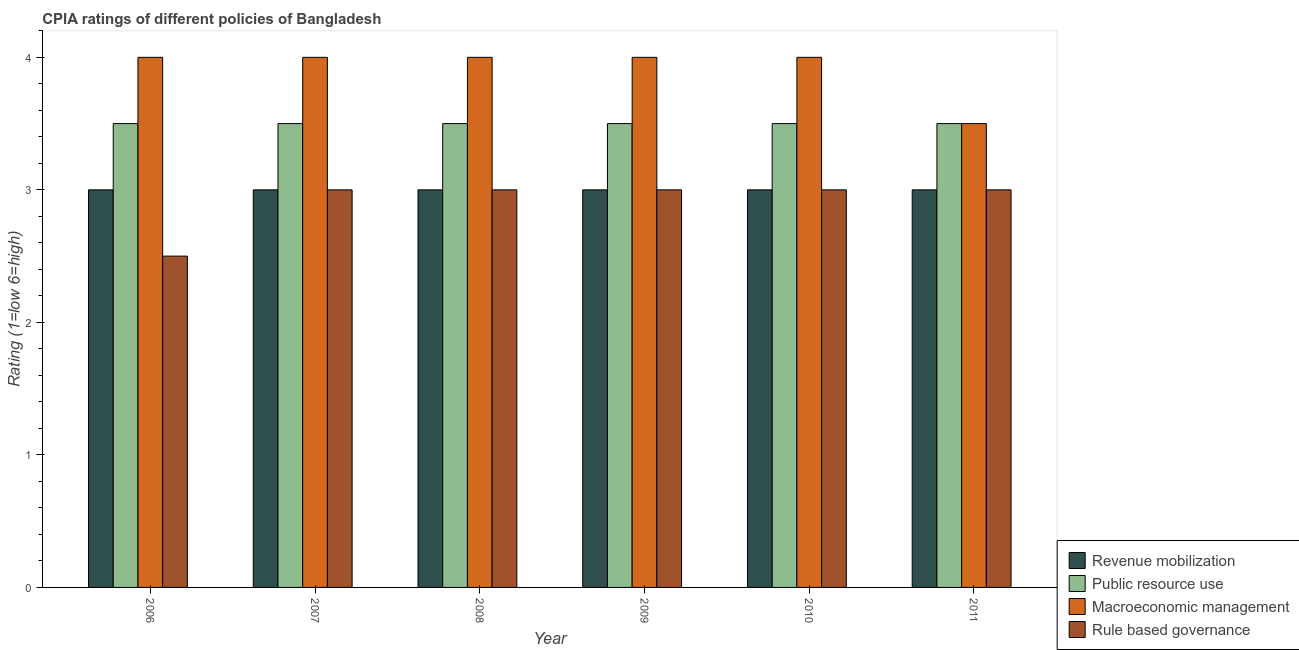How many different coloured bars are there?
Provide a succinct answer. 4. How many groups of bars are there?
Make the answer very short. 6. Are the number of bars per tick equal to the number of legend labels?
Provide a short and direct response. Yes. How many bars are there on the 2nd tick from the left?
Your answer should be very brief. 4. How many bars are there on the 6th tick from the right?
Your response must be concise. 4. What is the label of the 5th group of bars from the left?
Your response must be concise. 2010. Across all years, what is the minimum cpia rating of macroeconomic management?
Offer a terse response. 3.5. In which year was the cpia rating of macroeconomic management maximum?
Ensure brevity in your answer.  2006. What is the total cpia rating of revenue mobilization in the graph?
Your answer should be compact. 18. What is the difference between the cpia rating of rule based governance in 2010 and that in 2011?
Provide a short and direct response. 0. What is the average cpia rating of macroeconomic management per year?
Keep it short and to the point. 3.92. In the year 2011, what is the difference between the cpia rating of public resource use and cpia rating of rule based governance?
Make the answer very short. 0. In how many years, is the cpia rating of public resource use greater than 0.2?
Your answer should be very brief. 6. Is the difference between the cpia rating of rule based governance in 2010 and 2011 greater than the difference between the cpia rating of public resource use in 2010 and 2011?
Give a very brief answer. No. What is the difference between the highest and the lowest cpia rating of revenue mobilization?
Provide a succinct answer. 0. Is it the case that in every year, the sum of the cpia rating of rule based governance and cpia rating of revenue mobilization is greater than the sum of cpia rating of macroeconomic management and cpia rating of public resource use?
Give a very brief answer. No. What does the 1st bar from the left in 2007 represents?
Offer a very short reply. Revenue mobilization. What does the 3rd bar from the right in 2008 represents?
Ensure brevity in your answer.  Public resource use. Is it the case that in every year, the sum of the cpia rating of revenue mobilization and cpia rating of public resource use is greater than the cpia rating of macroeconomic management?
Offer a terse response. Yes. How many bars are there?
Give a very brief answer. 24. Are all the bars in the graph horizontal?
Ensure brevity in your answer.  No. Does the graph contain any zero values?
Your answer should be compact. No. Does the graph contain grids?
Give a very brief answer. No. What is the title of the graph?
Keep it short and to the point. CPIA ratings of different policies of Bangladesh. Does "Other expenses" appear as one of the legend labels in the graph?
Your answer should be compact. No. What is the label or title of the X-axis?
Provide a short and direct response. Year. What is the Rating (1=low 6=high) of Public resource use in 2006?
Make the answer very short. 3.5. What is the Rating (1=low 6=high) in Macroeconomic management in 2006?
Offer a terse response. 4. What is the Rating (1=low 6=high) in Revenue mobilization in 2007?
Keep it short and to the point. 3. What is the Rating (1=low 6=high) in Public resource use in 2007?
Provide a succinct answer. 3.5. What is the Rating (1=low 6=high) of Macroeconomic management in 2007?
Offer a very short reply. 4. What is the Rating (1=low 6=high) in Rule based governance in 2007?
Provide a succinct answer. 3. What is the Rating (1=low 6=high) in Macroeconomic management in 2008?
Give a very brief answer. 4. What is the Rating (1=low 6=high) of Macroeconomic management in 2009?
Make the answer very short. 4. What is the Rating (1=low 6=high) of Macroeconomic management in 2010?
Your answer should be compact. 4. What is the Rating (1=low 6=high) in Rule based governance in 2010?
Provide a short and direct response. 3. What is the Rating (1=low 6=high) of Macroeconomic management in 2011?
Give a very brief answer. 3.5. Across all years, what is the maximum Rating (1=low 6=high) of Public resource use?
Provide a succinct answer. 3.5. Across all years, what is the minimum Rating (1=low 6=high) in Public resource use?
Offer a terse response. 3.5. Across all years, what is the minimum Rating (1=low 6=high) of Rule based governance?
Provide a short and direct response. 2.5. What is the total Rating (1=low 6=high) of Revenue mobilization in the graph?
Keep it short and to the point. 18. What is the total Rating (1=low 6=high) in Rule based governance in the graph?
Offer a very short reply. 17.5. What is the difference between the Rating (1=low 6=high) of Macroeconomic management in 2006 and that in 2007?
Ensure brevity in your answer.  0. What is the difference between the Rating (1=low 6=high) of Revenue mobilization in 2006 and that in 2008?
Keep it short and to the point. 0. What is the difference between the Rating (1=low 6=high) of Macroeconomic management in 2006 and that in 2008?
Give a very brief answer. 0. What is the difference between the Rating (1=low 6=high) of Revenue mobilization in 2006 and that in 2009?
Ensure brevity in your answer.  0. What is the difference between the Rating (1=low 6=high) in Rule based governance in 2006 and that in 2009?
Ensure brevity in your answer.  -0.5. What is the difference between the Rating (1=low 6=high) of Public resource use in 2006 and that in 2010?
Your answer should be very brief. 0. What is the difference between the Rating (1=low 6=high) of Revenue mobilization in 2006 and that in 2011?
Offer a very short reply. 0. What is the difference between the Rating (1=low 6=high) in Public resource use in 2006 and that in 2011?
Offer a terse response. 0. What is the difference between the Rating (1=low 6=high) of Macroeconomic management in 2006 and that in 2011?
Make the answer very short. 0.5. What is the difference between the Rating (1=low 6=high) in Revenue mobilization in 2007 and that in 2008?
Provide a short and direct response. 0. What is the difference between the Rating (1=low 6=high) of Public resource use in 2007 and that in 2008?
Give a very brief answer. 0. What is the difference between the Rating (1=low 6=high) in Rule based governance in 2007 and that in 2008?
Provide a short and direct response. 0. What is the difference between the Rating (1=low 6=high) in Public resource use in 2007 and that in 2009?
Your response must be concise. 0. What is the difference between the Rating (1=low 6=high) in Rule based governance in 2007 and that in 2009?
Make the answer very short. 0. What is the difference between the Rating (1=low 6=high) in Revenue mobilization in 2007 and that in 2010?
Ensure brevity in your answer.  0. What is the difference between the Rating (1=low 6=high) in Revenue mobilization in 2007 and that in 2011?
Your answer should be very brief. 0. What is the difference between the Rating (1=low 6=high) in Macroeconomic management in 2007 and that in 2011?
Offer a terse response. 0.5. What is the difference between the Rating (1=low 6=high) in Rule based governance in 2007 and that in 2011?
Make the answer very short. 0. What is the difference between the Rating (1=low 6=high) in Revenue mobilization in 2008 and that in 2009?
Provide a short and direct response. 0. What is the difference between the Rating (1=low 6=high) of Macroeconomic management in 2008 and that in 2009?
Your response must be concise. 0. What is the difference between the Rating (1=low 6=high) in Revenue mobilization in 2008 and that in 2010?
Give a very brief answer. 0. What is the difference between the Rating (1=low 6=high) of Rule based governance in 2008 and that in 2010?
Provide a short and direct response. 0. What is the difference between the Rating (1=low 6=high) of Rule based governance in 2008 and that in 2011?
Your answer should be very brief. 0. What is the difference between the Rating (1=low 6=high) of Revenue mobilization in 2009 and that in 2010?
Give a very brief answer. 0. What is the difference between the Rating (1=low 6=high) of Macroeconomic management in 2009 and that in 2010?
Your answer should be very brief. 0. What is the difference between the Rating (1=low 6=high) in Revenue mobilization in 2009 and that in 2011?
Offer a very short reply. 0. What is the difference between the Rating (1=low 6=high) in Macroeconomic management in 2009 and that in 2011?
Keep it short and to the point. 0.5. What is the difference between the Rating (1=low 6=high) of Rule based governance in 2010 and that in 2011?
Your response must be concise. 0. What is the difference between the Rating (1=low 6=high) of Revenue mobilization in 2006 and the Rating (1=low 6=high) of Public resource use in 2007?
Provide a succinct answer. -0.5. What is the difference between the Rating (1=low 6=high) of Revenue mobilization in 2006 and the Rating (1=low 6=high) of Macroeconomic management in 2007?
Provide a short and direct response. -1. What is the difference between the Rating (1=low 6=high) of Revenue mobilization in 2006 and the Rating (1=low 6=high) of Public resource use in 2008?
Make the answer very short. -0.5. What is the difference between the Rating (1=low 6=high) of Public resource use in 2006 and the Rating (1=low 6=high) of Macroeconomic management in 2008?
Your answer should be compact. -0.5. What is the difference between the Rating (1=low 6=high) in Revenue mobilization in 2006 and the Rating (1=low 6=high) in Macroeconomic management in 2009?
Give a very brief answer. -1. What is the difference between the Rating (1=low 6=high) of Revenue mobilization in 2006 and the Rating (1=low 6=high) of Rule based governance in 2009?
Keep it short and to the point. 0. What is the difference between the Rating (1=low 6=high) in Public resource use in 2006 and the Rating (1=low 6=high) in Rule based governance in 2009?
Keep it short and to the point. 0.5. What is the difference between the Rating (1=low 6=high) of Macroeconomic management in 2006 and the Rating (1=low 6=high) of Rule based governance in 2009?
Your answer should be very brief. 1. What is the difference between the Rating (1=low 6=high) in Revenue mobilization in 2006 and the Rating (1=low 6=high) in Public resource use in 2010?
Offer a very short reply. -0.5. What is the difference between the Rating (1=low 6=high) in Public resource use in 2006 and the Rating (1=low 6=high) in Macroeconomic management in 2010?
Make the answer very short. -0.5. What is the difference between the Rating (1=low 6=high) in Public resource use in 2006 and the Rating (1=low 6=high) in Rule based governance in 2010?
Make the answer very short. 0.5. What is the difference between the Rating (1=low 6=high) in Macroeconomic management in 2006 and the Rating (1=low 6=high) in Rule based governance in 2010?
Ensure brevity in your answer.  1. What is the difference between the Rating (1=low 6=high) in Revenue mobilization in 2006 and the Rating (1=low 6=high) in Rule based governance in 2011?
Offer a very short reply. 0. What is the difference between the Rating (1=low 6=high) in Public resource use in 2006 and the Rating (1=low 6=high) in Rule based governance in 2011?
Keep it short and to the point. 0.5. What is the difference between the Rating (1=low 6=high) of Macroeconomic management in 2006 and the Rating (1=low 6=high) of Rule based governance in 2011?
Provide a succinct answer. 1. What is the difference between the Rating (1=low 6=high) of Revenue mobilization in 2007 and the Rating (1=low 6=high) of Public resource use in 2008?
Make the answer very short. -0.5. What is the difference between the Rating (1=low 6=high) in Revenue mobilization in 2007 and the Rating (1=low 6=high) in Macroeconomic management in 2008?
Keep it short and to the point. -1. What is the difference between the Rating (1=low 6=high) of Public resource use in 2007 and the Rating (1=low 6=high) of Macroeconomic management in 2008?
Provide a succinct answer. -0.5. What is the difference between the Rating (1=low 6=high) of Public resource use in 2007 and the Rating (1=low 6=high) of Rule based governance in 2008?
Give a very brief answer. 0.5. What is the difference between the Rating (1=low 6=high) in Revenue mobilization in 2007 and the Rating (1=low 6=high) in Public resource use in 2009?
Your answer should be compact. -0.5. What is the difference between the Rating (1=low 6=high) in Public resource use in 2007 and the Rating (1=low 6=high) in Rule based governance in 2009?
Your answer should be very brief. 0.5. What is the difference between the Rating (1=low 6=high) of Revenue mobilization in 2007 and the Rating (1=low 6=high) of Macroeconomic management in 2010?
Offer a terse response. -1. What is the difference between the Rating (1=low 6=high) in Public resource use in 2007 and the Rating (1=low 6=high) in Rule based governance in 2010?
Your response must be concise. 0.5. What is the difference between the Rating (1=low 6=high) in Revenue mobilization in 2007 and the Rating (1=low 6=high) in Public resource use in 2011?
Make the answer very short. -0.5. What is the difference between the Rating (1=low 6=high) in Public resource use in 2007 and the Rating (1=low 6=high) in Rule based governance in 2011?
Provide a succinct answer. 0.5. What is the difference between the Rating (1=low 6=high) in Revenue mobilization in 2008 and the Rating (1=low 6=high) in Public resource use in 2009?
Provide a short and direct response. -0.5. What is the difference between the Rating (1=low 6=high) of Revenue mobilization in 2008 and the Rating (1=low 6=high) of Macroeconomic management in 2009?
Offer a very short reply. -1. What is the difference between the Rating (1=low 6=high) of Revenue mobilization in 2008 and the Rating (1=low 6=high) of Rule based governance in 2009?
Make the answer very short. 0. What is the difference between the Rating (1=low 6=high) in Macroeconomic management in 2008 and the Rating (1=low 6=high) in Rule based governance in 2009?
Your answer should be compact. 1. What is the difference between the Rating (1=low 6=high) of Public resource use in 2008 and the Rating (1=low 6=high) of Macroeconomic management in 2010?
Your answer should be very brief. -0.5. What is the difference between the Rating (1=low 6=high) in Public resource use in 2008 and the Rating (1=low 6=high) in Rule based governance in 2010?
Ensure brevity in your answer.  0.5. What is the difference between the Rating (1=low 6=high) in Revenue mobilization in 2008 and the Rating (1=low 6=high) in Public resource use in 2011?
Offer a terse response. -0.5. What is the difference between the Rating (1=low 6=high) in Revenue mobilization in 2008 and the Rating (1=low 6=high) in Macroeconomic management in 2011?
Your answer should be very brief. -0.5. What is the difference between the Rating (1=low 6=high) in Revenue mobilization in 2008 and the Rating (1=low 6=high) in Rule based governance in 2011?
Your answer should be compact. 0. What is the difference between the Rating (1=low 6=high) of Public resource use in 2008 and the Rating (1=low 6=high) of Rule based governance in 2011?
Keep it short and to the point. 0.5. What is the difference between the Rating (1=low 6=high) of Macroeconomic management in 2008 and the Rating (1=low 6=high) of Rule based governance in 2011?
Make the answer very short. 1. What is the difference between the Rating (1=low 6=high) of Revenue mobilization in 2009 and the Rating (1=low 6=high) of Macroeconomic management in 2010?
Your response must be concise. -1. What is the difference between the Rating (1=low 6=high) of Revenue mobilization in 2009 and the Rating (1=low 6=high) of Rule based governance in 2010?
Keep it short and to the point. 0. What is the difference between the Rating (1=low 6=high) of Public resource use in 2009 and the Rating (1=low 6=high) of Macroeconomic management in 2010?
Give a very brief answer. -0.5. What is the difference between the Rating (1=low 6=high) of Public resource use in 2009 and the Rating (1=low 6=high) of Rule based governance in 2010?
Provide a succinct answer. 0.5. What is the difference between the Rating (1=low 6=high) of Macroeconomic management in 2009 and the Rating (1=low 6=high) of Rule based governance in 2010?
Keep it short and to the point. 1. What is the difference between the Rating (1=low 6=high) in Revenue mobilization in 2009 and the Rating (1=low 6=high) in Public resource use in 2011?
Keep it short and to the point. -0.5. What is the difference between the Rating (1=low 6=high) of Public resource use in 2009 and the Rating (1=low 6=high) of Rule based governance in 2011?
Make the answer very short. 0.5. What is the difference between the Rating (1=low 6=high) in Macroeconomic management in 2009 and the Rating (1=low 6=high) in Rule based governance in 2011?
Your answer should be compact. 1. What is the difference between the Rating (1=low 6=high) in Revenue mobilization in 2010 and the Rating (1=low 6=high) in Public resource use in 2011?
Your response must be concise. -0.5. What is the difference between the Rating (1=low 6=high) of Revenue mobilization in 2010 and the Rating (1=low 6=high) of Macroeconomic management in 2011?
Your answer should be compact. -0.5. What is the difference between the Rating (1=low 6=high) of Revenue mobilization in 2010 and the Rating (1=low 6=high) of Rule based governance in 2011?
Give a very brief answer. 0. What is the difference between the Rating (1=low 6=high) in Public resource use in 2010 and the Rating (1=low 6=high) in Rule based governance in 2011?
Give a very brief answer. 0.5. What is the difference between the Rating (1=low 6=high) of Macroeconomic management in 2010 and the Rating (1=low 6=high) of Rule based governance in 2011?
Keep it short and to the point. 1. What is the average Rating (1=low 6=high) in Revenue mobilization per year?
Make the answer very short. 3. What is the average Rating (1=low 6=high) in Macroeconomic management per year?
Provide a succinct answer. 3.92. What is the average Rating (1=low 6=high) in Rule based governance per year?
Ensure brevity in your answer.  2.92. In the year 2006, what is the difference between the Rating (1=low 6=high) of Revenue mobilization and Rating (1=low 6=high) of Macroeconomic management?
Your answer should be very brief. -1. In the year 2006, what is the difference between the Rating (1=low 6=high) in Public resource use and Rating (1=low 6=high) in Macroeconomic management?
Provide a short and direct response. -0.5. In the year 2006, what is the difference between the Rating (1=low 6=high) of Macroeconomic management and Rating (1=low 6=high) of Rule based governance?
Your answer should be compact. 1.5. In the year 2007, what is the difference between the Rating (1=low 6=high) of Revenue mobilization and Rating (1=low 6=high) of Macroeconomic management?
Your response must be concise. -1. In the year 2007, what is the difference between the Rating (1=low 6=high) of Public resource use and Rating (1=low 6=high) of Macroeconomic management?
Ensure brevity in your answer.  -0.5. In the year 2007, what is the difference between the Rating (1=low 6=high) in Macroeconomic management and Rating (1=low 6=high) in Rule based governance?
Your answer should be compact. 1. In the year 2008, what is the difference between the Rating (1=low 6=high) in Revenue mobilization and Rating (1=low 6=high) in Public resource use?
Offer a terse response. -0.5. In the year 2008, what is the difference between the Rating (1=low 6=high) in Public resource use and Rating (1=low 6=high) in Macroeconomic management?
Provide a short and direct response. -0.5. In the year 2009, what is the difference between the Rating (1=low 6=high) in Revenue mobilization and Rating (1=low 6=high) in Public resource use?
Ensure brevity in your answer.  -0.5. In the year 2009, what is the difference between the Rating (1=low 6=high) in Macroeconomic management and Rating (1=low 6=high) in Rule based governance?
Offer a terse response. 1. In the year 2010, what is the difference between the Rating (1=low 6=high) in Revenue mobilization and Rating (1=low 6=high) in Public resource use?
Offer a terse response. -0.5. In the year 2010, what is the difference between the Rating (1=low 6=high) in Revenue mobilization and Rating (1=low 6=high) in Rule based governance?
Keep it short and to the point. 0. In the year 2010, what is the difference between the Rating (1=low 6=high) in Public resource use and Rating (1=low 6=high) in Rule based governance?
Provide a succinct answer. 0.5. In the year 2010, what is the difference between the Rating (1=low 6=high) in Macroeconomic management and Rating (1=low 6=high) in Rule based governance?
Provide a short and direct response. 1. In the year 2011, what is the difference between the Rating (1=low 6=high) in Revenue mobilization and Rating (1=low 6=high) in Macroeconomic management?
Offer a very short reply. -0.5. In the year 2011, what is the difference between the Rating (1=low 6=high) in Public resource use and Rating (1=low 6=high) in Macroeconomic management?
Your answer should be compact. 0. In the year 2011, what is the difference between the Rating (1=low 6=high) of Public resource use and Rating (1=low 6=high) of Rule based governance?
Your answer should be compact. 0.5. What is the ratio of the Rating (1=low 6=high) of Public resource use in 2006 to that in 2007?
Your response must be concise. 1. What is the ratio of the Rating (1=low 6=high) of Rule based governance in 2006 to that in 2007?
Your answer should be compact. 0.83. What is the ratio of the Rating (1=low 6=high) in Public resource use in 2006 to that in 2008?
Keep it short and to the point. 1. What is the ratio of the Rating (1=low 6=high) in Macroeconomic management in 2006 to that in 2008?
Your answer should be compact. 1. What is the ratio of the Rating (1=low 6=high) in Revenue mobilization in 2006 to that in 2009?
Keep it short and to the point. 1. What is the ratio of the Rating (1=low 6=high) of Revenue mobilization in 2006 to that in 2010?
Offer a terse response. 1. What is the ratio of the Rating (1=low 6=high) of Macroeconomic management in 2006 to that in 2010?
Keep it short and to the point. 1. What is the ratio of the Rating (1=low 6=high) of Rule based governance in 2006 to that in 2010?
Provide a short and direct response. 0.83. What is the ratio of the Rating (1=low 6=high) of Revenue mobilization in 2006 to that in 2011?
Your answer should be very brief. 1. What is the ratio of the Rating (1=low 6=high) in Public resource use in 2006 to that in 2011?
Offer a terse response. 1. What is the ratio of the Rating (1=low 6=high) of Macroeconomic management in 2006 to that in 2011?
Your answer should be very brief. 1.14. What is the ratio of the Rating (1=low 6=high) of Public resource use in 2007 to that in 2008?
Ensure brevity in your answer.  1. What is the ratio of the Rating (1=low 6=high) of Revenue mobilization in 2007 to that in 2009?
Give a very brief answer. 1. What is the ratio of the Rating (1=low 6=high) in Macroeconomic management in 2007 to that in 2009?
Your response must be concise. 1. What is the ratio of the Rating (1=low 6=high) of Rule based governance in 2007 to that in 2010?
Provide a short and direct response. 1. What is the ratio of the Rating (1=low 6=high) of Revenue mobilization in 2007 to that in 2011?
Provide a succinct answer. 1. What is the ratio of the Rating (1=low 6=high) of Public resource use in 2007 to that in 2011?
Provide a succinct answer. 1. What is the ratio of the Rating (1=low 6=high) of Macroeconomic management in 2007 to that in 2011?
Your answer should be compact. 1.14. What is the ratio of the Rating (1=low 6=high) of Revenue mobilization in 2008 to that in 2010?
Give a very brief answer. 1. What is the ratio of the Rating (1=low 6=high) in Macroeconomic management in 2008 to that in 2010?
Ensure brevity in your answer.  1. What is the ratio of the Rating (1=low 6=high) of Rule based governance in 2008 to that in 2010?
Your response must be concise. 1. What is the ratio of the Rating (1=low 6=high) of Public resource use in 2008 to that in 2011?
Provide a short and direct response. 1. What is the ratio of the Rating (1=low 6=high) in Public resource use in 2009 to that in 2010?
Your answer should be very brief. 1. What is the ratio of the Rating (1=low 6=high) of Public resource use in 2009 to that in 2011?
Your response must be concise. 1. What is the ratio of the Rating (1=low 6=high) of Rule based governance in 2009 to that in 2011?
Provide a short and direct response. 1. What is the ratio of the Rating (1=low 6=high) of Macroeconomic management in 2010 to that in 2011?
Your response must be concise. 1.14. What is the difference between the highest and the second highest Rating (1=low 6=high) of Revenue mobilization?
Provide a short and direct response. 0. What is the difference between the highest and the second highest Rating (1=low 6=high) in Macroeconomic management?
Your response must be concise. 0. What is the difference between the highest and the second highest Rating (1=low 6=high) in Rule based governance?
Provide a succinct answer. 0. What is the difference between the highest and the lowest Rating (1=low 6=high) in Revenue mobilization?
Provide a succinct answer. 0. 